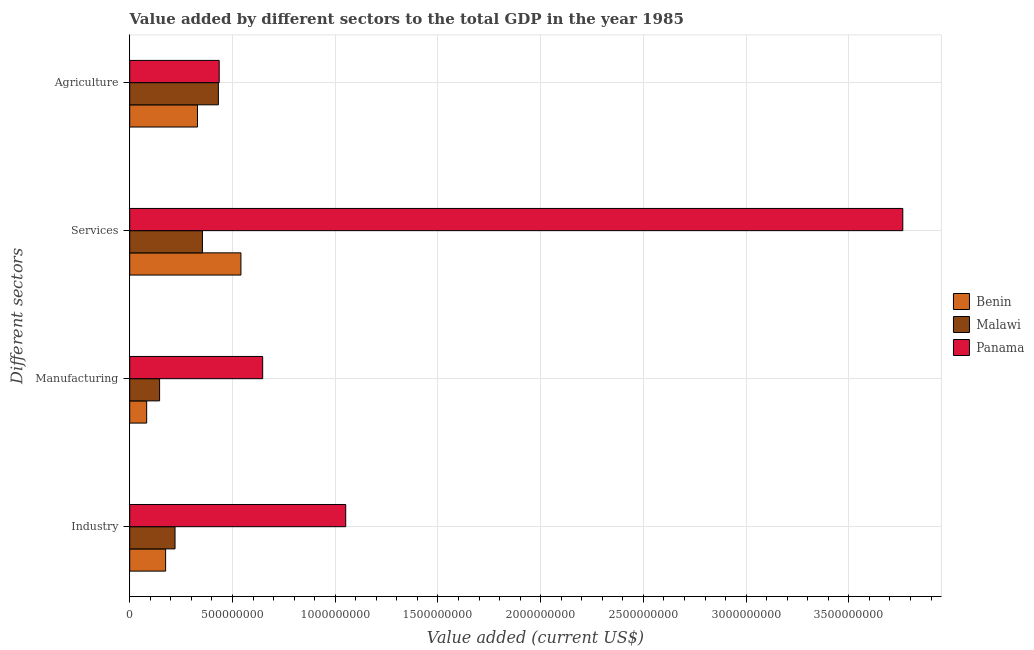Are the number of bars per tick equal to the number of legend labels?
Ensure brevity in your answer.  Yes. How many bars are there on the 1st tick from the bottom?
Your response must be concise. 3. What is the label of the 4th group of bars from the top?
Your answer should be very brief. Industry. What is the value added by industrial sector in Panama?
Your answer should be compact. 1.05e+09. Across all countries, what is the maximum value added by industrial sector?
Your answer should be very brief. 1.05e+09. Across all countries, what is the minimum value added by manufacturing sector?
Your answer should be compact. 8.25e+07. In which country was the value added by manufacturing sector maximum?
Your response must be concise. Panama. In which country was the value added by services sector minimum?
Provide a succinct answer. Malawi. What is the total value added by agricultural sector in the graph?
Your answer should be compact. 1.20e+09. What is the difference between the value added by manufacturing sector in Benin and that in Panama?
Your response must be concise. -5.65e+08. What is the difference between the value added by industrial sector in Benin and the value added by services sector in Malawi?
Offer a terse response. -1.79e+08. What is the average value added by manufacturing sector per country?
Offer a very short reply. 2.92e+08. What is the difference between the value added by agricultural sector and value added by industrial sector in Malawi?
Offer a very short reply. 2.11e+08. What is the ratio of the value added by industrial sector in Panama to that in Benin?
Ensure brevity in your answer.  6.02. Is the value added by agricultural sector in Panama less than that in Malawi?
Provide a short and direct response. No. What is the difference between the highest and the second highest value added by agricultural sector?
Offer a terse response. 4.07e+06. What is the difference between the highest and the lowest value added by services sector?
Your answer should be very brief. 3.41e+09. In how many countries, is the value added by services sector greater than the average value added by services sector taken over all countries?
Provide a succinct answer. 1. What does the 1st bar from the top in Manufacturing represents?
Your response must be concise. Panama. What does the 3rd bar from the bottom in Manufacturing represents?
Give a very brief answer. Panama. Is it the case that in every country, the sum of the value added by industrial sector and value added by manufacturing sector is greater than the value added by services sector?
Offer a very short reply. No. How many bars are there?
Offer a very short reply. 12. Are all the bars in the graph horizontal?
Keep it short and to the point. Yes. Are the values on the major ticks of X-axis written in scientific E-notation?
Your response must be concise. No. Does the graph contain any zero values?
Make the answer very short. No. How many legend labels are there?
Give a very brief answer. 3. How are the legend labels stacked?
Offer a very short reply. Vertical. What is the title of the graph?
Provide a short and direct response. Value added by different sectors to the total GDP in the year 1985. Does "Equatorial Guinea" appear as one of the legend labels in the graph?
Your response must be concise. No. What is the label or title of the X-axis?
Offer a very short reply. Value added (current US$). What is the label or title of the Y-axis?
Your response must be concise. Different sectors. What is the Value added (current US$) in Benin in Industry?
Your response must be concise. 1.75e+08. What is the Value added (current US$) in Malawi in Industry?
Offer a terse response. 2.20e+08. What is the Value added (current US$) of Panama in Industry?
Ensure brevity in your answer.  1.05e+09. What is the Value added (current US$) in Benin in Manufacturing?
Offer a very short reply. 8.25e+07. What is the Value added (current US$) of Malawi in Manufacturing?
Your answer should be compact. 1.45e+08. What is the Value added (current US$) of Panama in Manufacturing?
Offer a terse response. 6.47e+08. What is the Value added (current US$) of Benin in Services?
Offer a terse response. 5.41e+08. What is the Value added (current US$) of Malawi in Services?
Provide a succinct answer. 3.54e+08. What is the Value added (current US$) of Panama in Services?
Give a very brief answer. 3.76e+09. What is the Value added (current US$) in Benin in Agriculture?
Ensure brevity in your answer.  3.30e+08. What is the Value added (current US$) of Malawi in Agriculture?
Your answer should be compact. 4.31e+08. What is the Value added (current US$) in Panama in Agriculture?
Provide a short and direct response. 4.36e+08. Across all Different sectors, what is the maximum Value added (current US$) of Benin?
Keep it short and to the point. 5.41e+08. Across all Different sectors, what is the maximum Value added (current US$) of Malawi?
Provide a short and direct response. 4.31e+08. Across all Different sectors, what is the maximum Value added (current US$) in Panama?
Keep it short and to the point. 3.76e+09. Across all Different sectors, what is the minimum Value added (current US$) of Benin?
Your answer should be very brief. 8.25e+07. Across all Different sectors, what is the minimum Value added (current US$) in Malawi?
Make the answer very short. 1.45e+08. Across all Different sectors, what is the minimum Value added (current US$) in Panama?
Provide a short and direct response. 4.36e+08. What is the total Value added (current US$) of Benin in the graph?
Your answer should be compact. 1.13e+09. What is the total Value added (current US$) of Malawi in the graph?
Make the answer very short. 1.15e+09. What is the total Value added (current US$) in Panama in the graph?
Your answer should be very brief. 5.90e+09. What is the difference between the Value added (current US$) in Benin in Industry and that in Manufacturing?
Make the answer very short. 9.22e+07. What is the difference between the Value added (current US$) in Malawi in Industry and that in Manufacturing?
Offer a very short reply. 7.51e+07. What is the difference between the Value added (current US$) of Panama in Industry and that in Manufacturing?
Make the answer very short. 4.04e+08. What is the difference between the Value added (current US$) in Benin in Industry and that in Services?
Your response must be concise. -3.67e+08. What is the difference between the Value added (current US$) in Malawi in Industry and that in Services?
Keep it short and to the point. -1.33e+08. What is the difference between the Value added (current US$) of Panama in Industry and that in Services?
Your answer should be very brief. -2.71e+09. What is the difference between the Value added (current US$) in Benin in Industry and that in Agriculture?
Your answer should be compact. -1.55e+08. What is the difference between the Value added (current US$) in Malawi in Industry and that in Agriculture?
Offer a very short reply. -2.11e+08. What is the difference between the Value added (current US$) of Panama in Industry and that in Agriculture?
Offer a very short reply. 6.16e+08. What is the difference between the Value added (current US$) of Benin in Manufacturing and that in Services?
Offer a very short reply. -4.59e+08. What is the difference between the Value added (current US$) of Malawi in Manufacturing and that in Services?
Your answer should be very brief. -2.08e+08. What is the difference between the Value added (current US$) of Panama in Manufacturing and that in Services?
Your response must be concise. -3.12e+09. What is the difference between the Value added (current US$) in Benin in Manufacturing and that in Agriculture?
Give a very brief answer. -2.47e+08. What is the difference between the Value added (current US$) in Malawi in Manufacturing and that in Agriculture?
Provide a short and direct response. -2.86e+08. What is the difference between the Value added (current US$) in Panama in Manufacturing and that in Agriculture?
Provide a succinct answer. 2.12e+08. What is the difference between the Value added (current US$) in Benin in Services and that in Agriculture?
Offer a very short reply. 2.11e+08. What is the difference between the Value added (current US$) of Malawi in Services and that in Agriculture?
Ensure brevity in your answer.  -7.76e+07. What is the difference between the Value added (current US$) of Panama in Services and that in Agriculture?
Your answer should be compact. 3.33e+09. What is the difference between the Value added (current US$) in Benin in Industry and the Value added (current US$) in Malawi in Manufacturing?
Your response must be concise. 2.93e+07. What is the difference between the Value added (current US$) in Benin in Industry and the Value added (current US$) in Panama in Manufacturing?
Your response must be concise. -4.72e+08. What is the difference between the Value added (current US$) in Malawi in Industry and the Value added (current US$) in Panama in Manufacturing?
Provide a succinct answer. -4.27e+08. What is the difference between the Value added (current US$) in Benin in Industry and the Value added (current US$) in Malawi in Services?
Your answer should be very brief. -1.79e+08. What is the difference between the Value added (current US$) in Benin in Industry and the Value added (current US$) in Panama in Services?
Your answer should be compact. -3.59e+09. What is the difference between the Value added (current US$) of Malawi in Industry and the Value added (current US$) of Panama in Services?
Your response must be concise. -3.54e+09. What is the difference between the Value added (current US$) in Benin in Industry and the Value added (current US$) in Malawi in Agriculture?
Make the answer very short. -2.57e+08. What is the difference between the Value added (current US$) in Benin in Industry and the Value added (current US$) in Panama in Agriculture?
Keep it short and to the point. -2.61e+08. What is the difference between the Value added (current US$) of Malawi in Industry and the Value added (current US$) of Panama in Agriculture?
Give a very brief answer. -2.15e+08. What is the difference between the Value added (current US$) of Benin in Manufacturing and the Value added (current US$) of Malawi in Services?
Keep it short and to the point. -2.71e+08. What is the difference between the Value added (current US$) in Benin in Manufacturing and the Value added (current US$) in Panama in Services?
Make the answer very short. -3.68e+09. What is the difference between the Value added (current US$) of Malawi in Manufacturing and the Value added (current US$) of Panama in Services?
Your answer should be very brief. -3.62e+09. What is the difference between the Value added (current US$) of Benin in Manufacturing and the Value added (current US$) of Malawi in Agriculture?
Your answer should be very brief. -3.49e+08. What is the difference between the Value added (current US$) in Benin in Manufacturing and the Value added (current US$) in Panama in Agriculture?
Ensure brevity in your answer.  -3.53e+08. What is the difference between the Value added (current US$) in Malawi in Manufacturing and the Value added (current US$) in Panama in Agriculture?
Provide a short and direct response. -2.90e+08. What is the difference between the Value added (current US$) in Benin in Services and the Value added (current US$) in Malawi in Agriculture?
Offer a very short reply. 1.10e+08. What is the difference between the Value added (current US$) of Benin in Services and the Value added (current US$) of Panama in Agriculture?
Make the answer very short. 1.06e+08. What is the difference between the Value added (current US$) in Malawi in Services and the Value added (current US$) in Panama in Agriculture?
Your response must be concise. -8.17e+07. What is the average Value added (current US$) in Benin per Different sectors?
Provide a short and direct response. 2.82e+08. What is the average Value added (current US$) of Malawi per Different sectors?
Give a very brief answer. 2.88e+08. What is the average Value added (current US$) of Panama per Different sectors?
Provide a short and direct response. 1.47e+09. What is the difference between the Value added (current US$) of Benin and Value added (current US$) of Malawi in Industry?
Ensure brevity in your answer.  -4.58e+07. What is the difference between the Value added (current US$) of Benin and Value added (current US$) of Panama in Industry?
Make the answer very short. -8.77e+08. What is the difference between the Value added (current US$) in Malawi and Value added (current US$) in Panama in Industry?
Ensure brevity in your answer.  -8.31e+08. What is the difference between the Value added (current US$) in Benin and Value added (current US$) in Malawi in Manufacturing?
Make the answer very short. -6.29e+07. What is the difference between the Value added (current US$) in Benin and Value added (current US$) in Panama in Manufacturing?
Your answer should be very brief. -5.65e+08. What is the difference between the Value added (current US$) in Malawi and Value added (current US$) in Panama in Manufacturing?
Give a very brief answer. -5.02e+08. What is the difference between the Value added (current US$) of Benin and Value added (current US$) of Malawi in Services?
Provide a succinct answer. 1.87e+08. What is the difference between the Value added (current US$) of Benin and Value added (current US$) of Panama in Services?
Keep it short and to the point. -3.22e+09. What is the difference between the Value added (current US$) of Malawi and Value added (current US$) of Panama in Services?
Make the answer very short. -3.41e+09. What is the difference between the Value added (current US$) of Benin and Value added (current US$) of Malawi in Agriculture?
Make the answer very short. -1.02e+08. What is the difference between the Value added (current US$) of Benin and Value added (current US$) of Panama in Agriculture?
Give a very brief answer. -1.06e+08. What is the difference between the Value added (current US$) of Malawi and Value added (current US$) of Panama in Agriculture?
Offer a very short reply. -4.07e+06. What is the ratio of the Value added (current US$) of Benin in Industry to that in Manufacturing?
Make the answer very short. 2.12. What is the ratio of the Value added (current US$) of Malawi in Industry to that in Manufacturing?
Your answer should be compact. 1.52. What is the ratio of the Value added (current US$) in Panama in Industry to that in Manufacturing?
Your response must be concise. 1.62. What is the ratio of the Value added (current US$) in Benin in Industry to that in Services?
Offer a terse response. 0.32. What is the ratio of the Value added (current US$) of Malawi in Industry to that in Services?
Your answer should be very brief. 0.62. What is the ratio of the Value added (current US$) in Panama in Industry to that in Services?
Provide a short and direct response. 0.28. What is the ratio of the Value added (current US$) in Benin in Industry to that in Agriculture?
Make the answer very short. 0.53. What is the ratio of the Value added (current US$) of Malawi in Industry to that in Agriculture?
Provide a succinct answer. 0.51. What is the ratio of the Value added (current US$) in Panama in Industry to that in Agriculture?
Ensure brevity in your answer.  2.41. What is the ratio of the Value added (current US$) of Benin in Manufacturing to that in Services?
Provide a short and direct response. 0.15. What is the ratio of the Value added (current US$) in Malawi in Manufacturing to that in Services?
Offer a very short reply. 0.41. What is the ratio of the Value added (current US$) of Panama in Manufacturing to that in Services?
Your answer should be very brief. 0.17. What is the ratio of the Value added (current US$) of Benin in Manufacturing to that in Agriculture?
Keep it short and to the point. 0.25. What is the ratio of the Value added (current US$) in Malawi in Manufacturing to that in Agriculture?
Provide a succinct answer. 0.34. What is the ratio of the Value added (current US$) in Panama in Manufacturing to that in Agriculture?
Ensure brevity in your answer.  1.49. What is the ratio of the Value added (current US$) in Benin in Services to that in Agriculture?
Your answer should be compact. 1.64. What is the ratio of the Value added (current US$) of Malawi in Services to that in Agriculture?
Give a very brief answer. 0.82. What is the ratio of the Value added (current US$) in Panama in Services to that in Agriculture?
Ensure brevity in your answer.  8.64. What is the difference between the highest and the second highest Value added (current US$) of Benin?
Offer a terse response. 2.11e+08. What is the difference between the highest and the second highest Value added (current US$) of Malawi?
Provide a succinct answer. 7.76e+07. What is the difference between the highest and the second highest Value added (current US$) of Panama?
Offer a very short reply. 2.71e+09. What is the difference between the highest and the lowest Value added (current US$) of Benin?
Your response must be concise. 4.59e+08. What is the difference between the highest and the lowest Value added (current US$) of Malawi?
Your answer should be compact. 2.86e+08. What is the difference between the highest and the lowest Value added (current US$) in Panama?
Provide a succinct answer. 3.33e+09. 